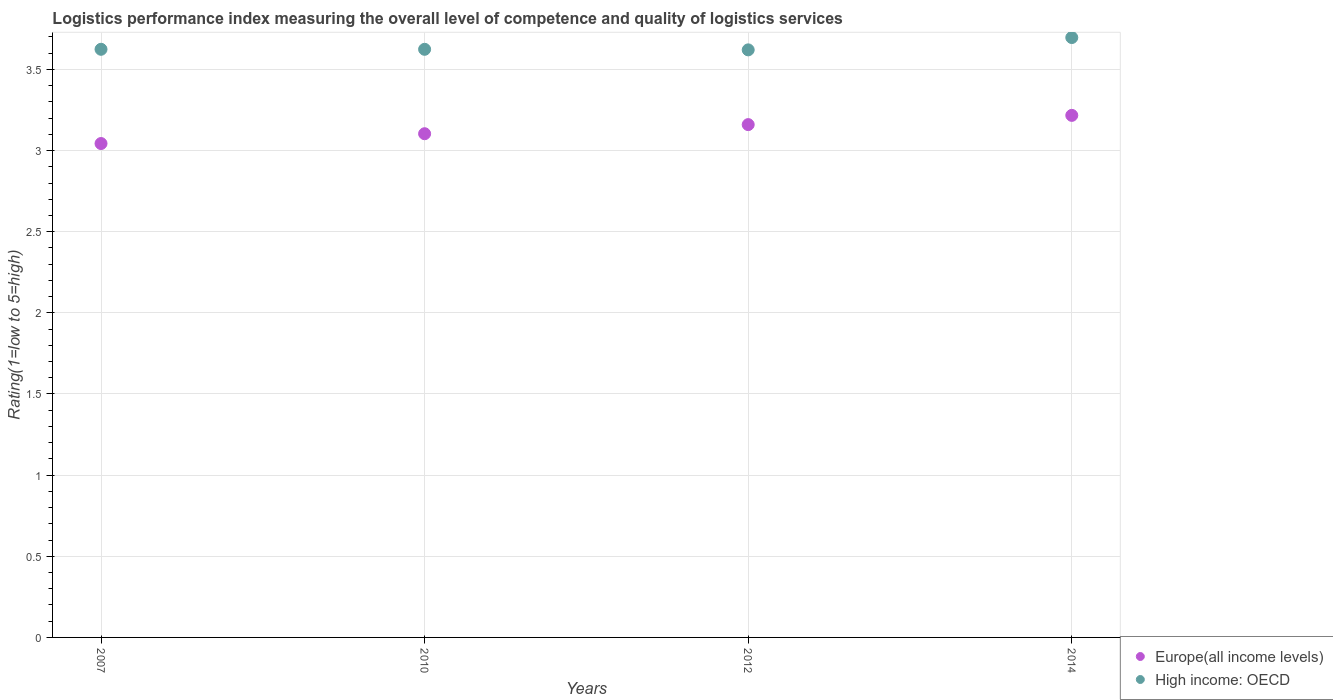What is the Logistic performance index in High income: OECD in 2014?
Ensure brevity in your answer.  3.7. Across all years, what is the maximum Logistic performance index in High income: OECD?
Your answer should be compact. 3.7. Across all years, what is the minimum Logistic performance index in High income: OECD?
Keep it short and to the point. 3.62. In which year was the Logistic performance index in High income: OECD maximum?
Offer a terse response. 2014. What is the total Logistic performance index in High income: OECD in the graph?
Offer a very short reply. 14.56. What is the difference between the Logistic performance index in High income: OECD in 2010 and that in 2012?
Your answer should be compact. 0. What is the difference between the Logistic performance index in High income: OECD in 2014 and the Logistic performance index in Europe(all income levels) in 2007?
Provide a succinct answer. 0.65. What is the average Logistic performance index in High income: OECD per year?
Offer a very short reply. 3.64. In the year 2010, what is the difference between the Logistic performance index in High income: OECD and Logistic performance index in Europe(all income levels)?
Your response must be concise. 0.52. In how many years, is the Logistic performance index in Europe(all income levels) greater than 1.2?
Your response must be concise. 4. What is the ratio of the Logistic performance index in Europe(all income levels) in 2007 to that in 2014?
Provide a succinct answer. 0.95. Is the difference between the Logistic performance index in High income: OECD in 2007 and 2012 greater than the difference between the Logistic performance index in Europe(all income levels) in 2007 and 2012?
Ensure brevity in your answer.  Yes. What is the difference between the highest and the second highest Logistic performance index in Europe(all income levels)?
Your answer should be compact. 0.06. What is the difference between the highest and the lowest Logistic performance index in High income: OECD?
Your answer should be very brief. 0.08. In how many years, is the Logistic performance index in Europe(all income levels) greater than the average Logistic performance index in Europe(all income levels) taken over all years?
Provide a succinct answer. 2. Is the Logistic performance index in High income: OECD strictly less than the Logistic performance index in Europe(all income levels) over the years?
Provide a succinct answer. No. What is the difference between two consecutive major ticks on the Y-axis?
Your answer should be compact. 0.5. Are the values on the major ticks of Y-axis written in scientific E-notation?
Make the answer very short. No. Does the graph contain any zero values?
Your answer should be very brief. No. Does the graph contain grids?
Give a very brief answer. Yes. Where does the legend appear in the graph?
Provide a succinct answer. Bottom right. What is the title of the graph?
Make the answer very short. Logistics performance index measuring the overall level of competence and quality of logistics services. What is the label or title of the X-axis?
Keep it short and to the point. Years. What is the label or title of the Y-axis?
Offer a very short reply. Rating(1=low to 5=high). What is the Rating(1=low to 5=high) of Europe(all income levels) in 2007?
Ensure brevity in your answer.  3.04. What is the Rating(1=low to 5=high) of High income: OECD in 2007?
Make the answer very short. 3.62. What is the Rating(1=low to 5=high) in Europe(all income levels) in 2010?
Keep it short and to the point. 3.1. What is the Rating(1=low to 5=high) in High income: OECD in 2010?
Give a very brief answer. 3.62. What is the Rating(1=low to 5=high) of Europe(all income levels) in 2012?
Offer a very short reply. 3.16. What is the Rating(1=low to 5=high) in High income: OECD in 2012?
Offer a very short reply. 3.62. What is the Rating(1=low to 5=high) in Europe(all income levels) in 2014?
Give a very brief answer. 3.22. What is the Rating(1=low to 5=high) of High income: OECD in 2014?
Provide a short and direct response. 3.7. Across all years, what is the maximum Rating(1=low to 5=high) in Europe(all income levels)?
Give a very brief answer. 3.22. Across all years, what is the maximum Rating(1=low to 5=high) in High income: OECD?
Your response must be concise. 3.7. Across all years, what is the minimum Rating(1=low to 5=high) in Europe(all income levels)?
Your response must be concise. 3.04. Across all years, what is the minimum Rating(1=low to 5=high) in High income: OECD?
Offer a very short reply. 3.62. What is the total Rating(1=low to 5=high) of Europe(all income levels) in the graph?
Keep it short and to the point. 12.52. What is the total Rating(1=low to 5=high) in High income: OECD in the graph?
Offer a terse response. 14.56. What is the difference between the Rating(1=low to 5=high) of Europe(all income levels) in 2007 and that in 2010?
Offer a terse response. -0.06. What is the difference between the Rating(1=low to 5=high) in Europe(all income levels) in 2007 and that in 2012?
Your answer should be compact. -0.12. What is the difference between the Rating(1=low to 5=high) in High income: OECD in 2007 and that in 2012?
Provide a succinct answer. 0. What is the difference between the Rating(1=low to 5=high) of Europe(all income levels) in 2007 and that in 2014?
Keep it short and to the point. -0.17. What is the difference between the Rating(1=low to 5=high) of High income: OECD in 2007 and that in 2014?
Offer a terse response. -0.07. What is the difference between the Rating(1=low to 5=high) of Europe(all income levels) in 2010 and that in 2012?
Your answer should be very brief. -0.06. What is the difference between the Rating(1=low to 5=high) of High income: OECD in 2010 and that in 2012?
Your response must be concise. 0. What is the difference between the Rating(1=low to 5=high) in Europe(all income levels) in 2010 and that in 2014?
Provide a short and direct response. -0.11. What is the difference between the Rating(1=low to 5=high) in High income: OECD in 2010 and that in 2014?
Ensure brevity in your answer.  -0.07. What is the difference between the Rating(1=low to 5=high) in Europe(all income levels) in 2012 and that in 2014?
Provide a short and direct response. -0.06. What is the difference between the Rating(1=low to 5=high) in High income: OECD in 2012 and that in 2014?
Keep it short and to the point. -0.08. What is the difference between the Rating(1=low to 5=high) of Europe(all income levels) in 2007 and the Rating(1=low to 5=high) of High income: OECD in 2010?
Your answer should be very brief. -0.58. What is the difference between the Rating(1=low to 5=high) of Europe(all income levels) in 2007 and the Rating(1=low to 5=high) of High income: OECD in 2012?
Your answer should be very brief. -0.58. What is the difference between the Rating(1=low to 5=high) in Europe(all income levels) in 2007 and the Rating(1=low to 5=high) in High income: OECD in 2014?
Provide a succinct answer. -0.65. What is the difference between the Rating(1=low to 5=high) of Europe(all income levels) in 2010 and the Rating(1=low to 5=high) of High income: OECD in 2012?
Ensure brevity in your answer.  -0.52. What is the difference between the Rating(1=low to 5=high) in Europe(all income levels) in 2010 and the Rating(1=low to 5=high) in High income: OECD in 2014?
Your answer should be compact. -0.59. What is the difference between the Rating(1=low to 5=high) in Europe(all income levels) in 2012 and the Rating(1=low to 5=high) in High income: OECD in 2014?
Keep it short and to the point. -0.54. What is the average Rating(1=low to 5=high) of Europe(all income levels) per year?
Your answer should be very brief. 3.13. What is the average Rating(1=low to 5=high) in High income: OECD per year?
Your answer should be very brief. 3.64. In the year 2007, what is the difference between the Rating(1=low to 5=high) in Europe(all income levels) and Rating(1=low to 5=high) in High income: OECD?
Your answer should be very brief. -0.58. In the year 2010, what is the difference between the Rating(1=low to 5=high) in Europe(all income levels) and Rating(1=low to 5=high) in High income: OECD?
Your response must be concise. -0.52. In the year 2012, what is the difference between the Rating(1=low to 5=high) in Europe(all income levels) and Rating(1=low to 5=high) in High income: OECD?
Make the answer very short. -0.46. In the year 2014, what is the difference between the Rating(1=low to 5=high) of Europe(all income levels) and Rating(1=low to 5=high) of High income: OECD?
Offer a terse response. -0.48. What is the ratio of the Rating(1=low to 5=high) in Europe(all income levels) in 2007 to that in 2010?
Keep it short and to the point. 0.98. What is the ratio of the Rating(1=low to 5=high) of Europe(all income levels) in 2007 to that in 2012?
Provide a succinct answer. 0.96. What is the ratio of the Rating(1=low to 5=high) in Europe(all income levels) in 2007 to that in 2014?
Make the answer very short. 0.95. What is the ratio of the Rating(1=low to 5=high) in High income: OECD in 2007 to that in 2014?
Your response must be concise. 0.98. What is the ratio of the Rating(1=low to 5=high) of Europe(all income levels) in 2010 to that in 2012?
Provide a succinct answer. 0.98. What is the ratio of the Rating(1=low to 5=high) of High income: OECD in 2010 to that in 2012?
Offer a terse response. 1. What is the ratio of the Rating(1=low to 5=high) in Europe(all income levels) in 2010 to that in 2014?
Offer a terse response. 0.96. What is the ratio of the Rating(1=low to 5=high) in High income: OECD in 2010 to that in 2014?
Ensure brevity in your answer.  0.98. What is the ratio of the Rating(1=low to 5=high) in Europe(all income levels) in 2012 to that in 2014?
Offer a very short reply. 0.98. What is the ratio of the Rating(1=low to 5=high) of High income: OECD in 2012 to that in 2014?
Keep it short and to the point. 0.98. What is the difference between the highest and the second highest Rating(1=low to 5=high) of Europe(all income levels)?
Your answer should be very brief. 0.06. What is the difference between the highest and the second highest Rating(1=low to 5=high) in High income: OECD?
Your answer should be very brief. 0.07. What is the difference between the highest and the lowest Rating(1=low to 5=high) of Europe(all income levels)?
Ensure brevity in your answer.  0.17. What is the difference between the highest and the lowest Rating(1=low to 5=high) in High income: OECD?
Your response must be concise. 0.08. 